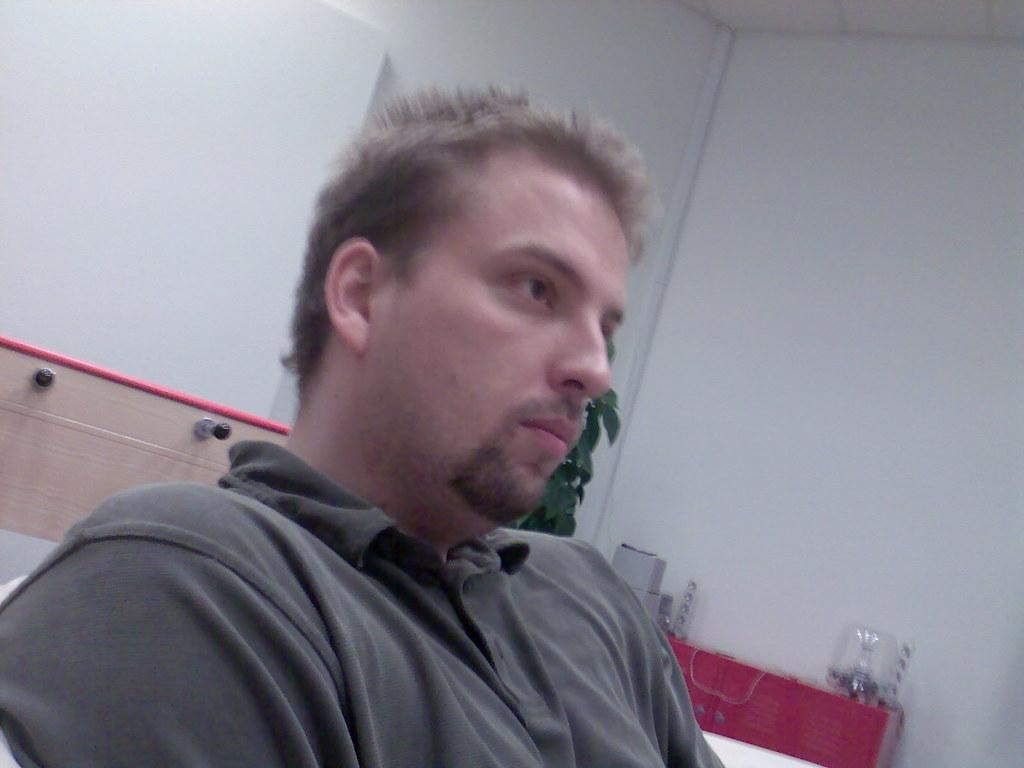What is the main subject of the image? There is a person in the image. What can be seen on the right side of the person? There are objects at the right side of the person. What type of object is located behind the person? There is a wooden object behind the person. How many girls are swimming in the lake in the image? There is no girl or lake present in the image; it features a person with objects on the right side and a wooden object behind them. 